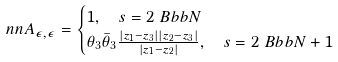<formula> <loc_0><loc_0><loc_500><loc_500>\ n n & A _ { \epsilon , \epsilon } = \begin{cases} 1 , \quad s = 2 \ B b b N \\ \theta _ { 3 } \bar { \theta } _ { 3 } \frac { | z _ { 1 } - z _ { 3 } | | z _ { 2 } - z _ { 3 } | } { | z _ { 1 } - z _ { 2 } | } , \quad s = 2 \ B b b N + 1 \end{cases}</formula> 